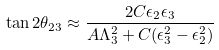Convert formula to latex. <formula><loc_0><loc_0><loc_500><loc_500>\tan 2 \theta _ { 2 3 } \approx \frac { 2 C \epsilon _ { 2 } \epsilon _ { 3 } } { A \Lambda _ { 3 } ^ { 2 } + C ( \epsilon _ { 3 } ^ { 2 } - \epsilon _ { 2 } ^ { 2 } ) }</formula> 